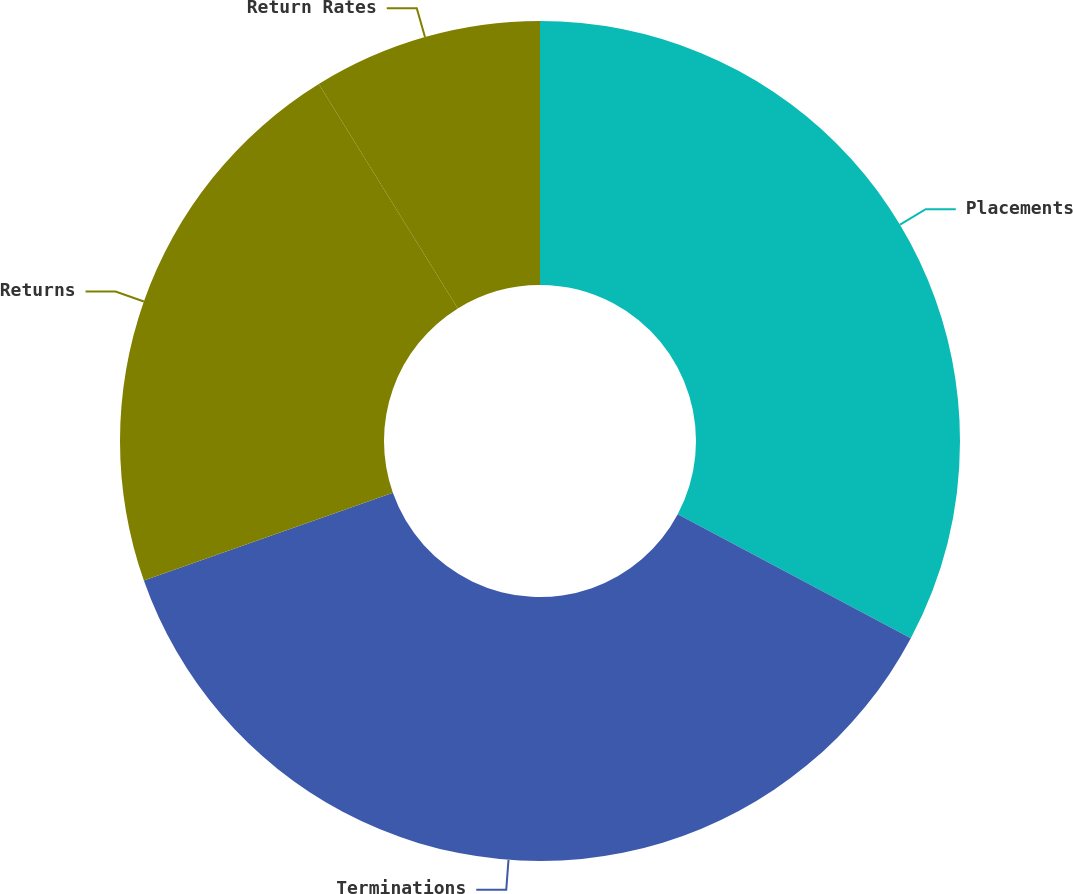Convert chart to OTSL. <chart><loc_0><loc_0><loc_500><loc_500><pie_chart><fcel>Placements<fcel>Terminations<fcel>Returns<fcel>Return Rates<nl><fcel>32.78%<fcel>36.83%<fcel>21.56%<fcel>8.83%<nl></chart> 